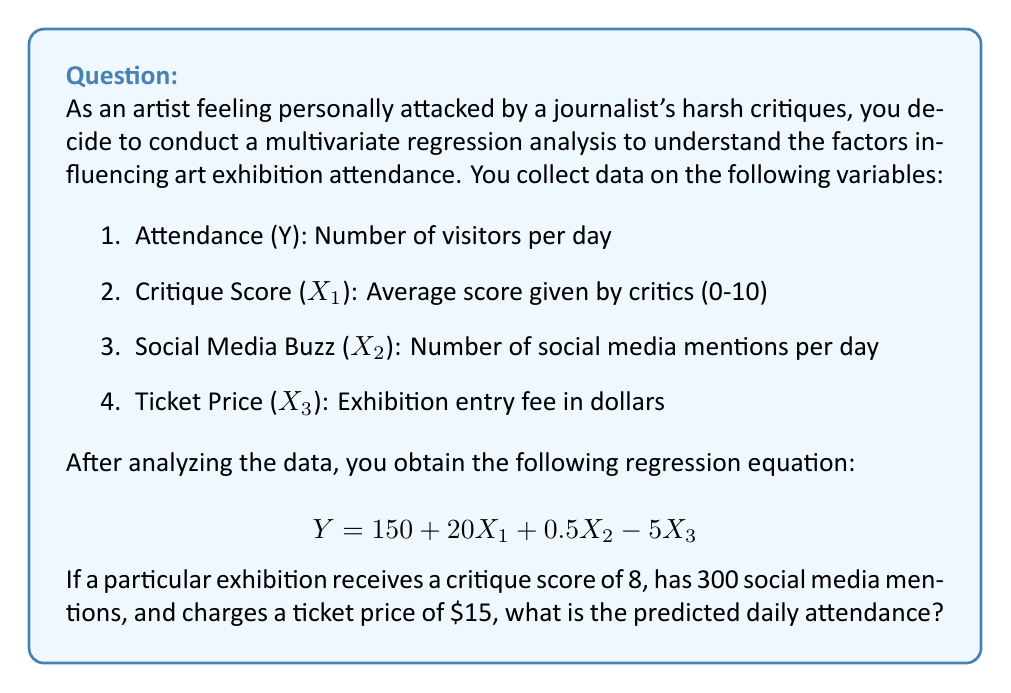Can you solve this math problem? To solve this problem, we need to use the given multivariate regression equation and substitute the values for each variable. Let's break it down step by step:

1. The regression equation is:
   $$Y = 150 + 20X_1 + 0.5X_2 - 5X_3$$

2. We have the following values:
   - Critique Score (X₁) = 8
   - Social Media Buzz (X₂) = 300
   - Ticket Price (X₃) = 15

3. Let's substitute these values into the equation:
   $$Y = 150 + 20(8) + 0.5(300) - 5(15)$$

4. Now, let's calculate each term:
   - 150 (constant term)
   - 20(8) = 160
   - 0.5(300) = 150
   - -5(15) = -75

5. Sum up all the terms:
   $$Y = 150 + 160 + 150 - 75$$

6. Perform the final calculation:
   $$Y = 385$$

Therefore, the predicted daily attendance for the exhibition is 385 visitors.
Answer: 385 visitors 